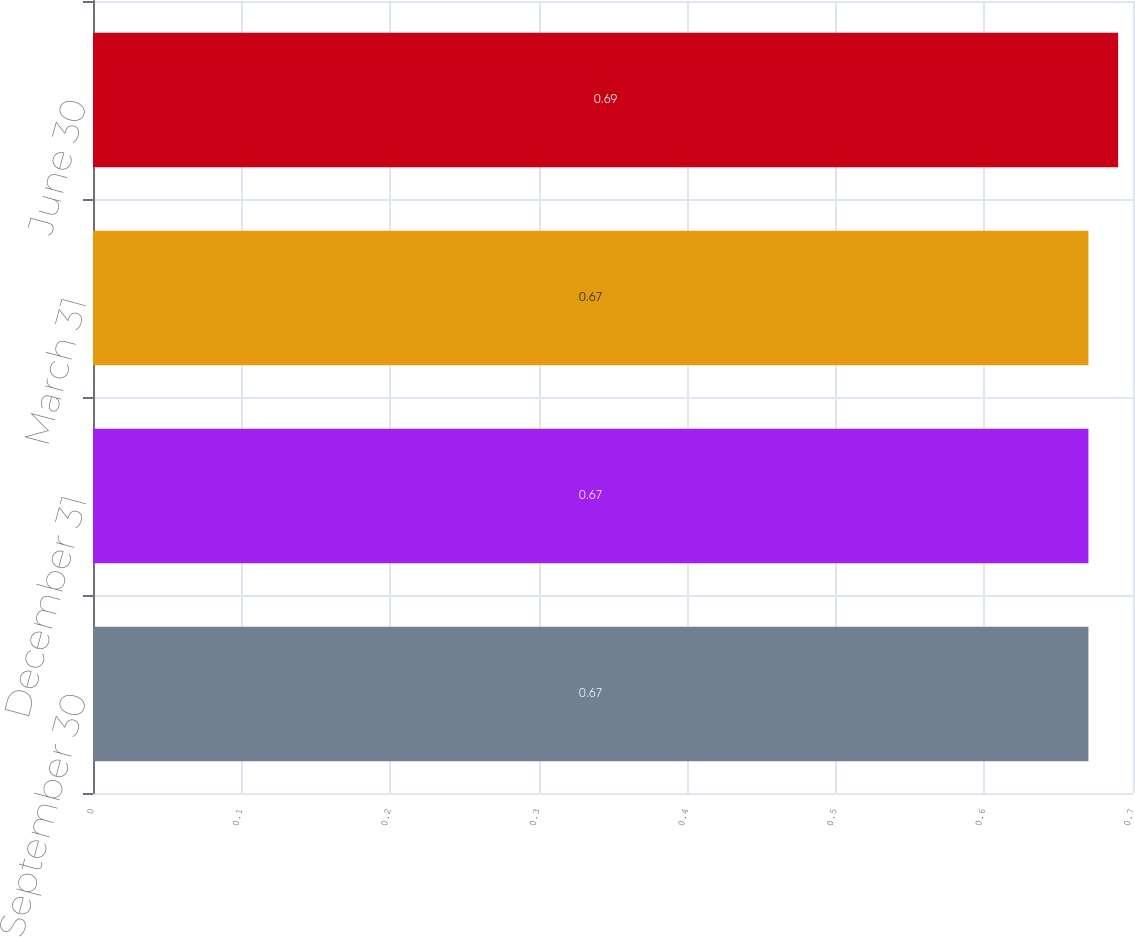Convert chart to OTSL. <chart><loc_0><loc_0><loc_500><loc_500><bar_chart><fcel>September 30<fcel>December 31<fcel>March 31<fcel>June 30<nl><fcel>0.67<fcel>0.67<fcel>0.67<fcel>0.69<nl></chart> 